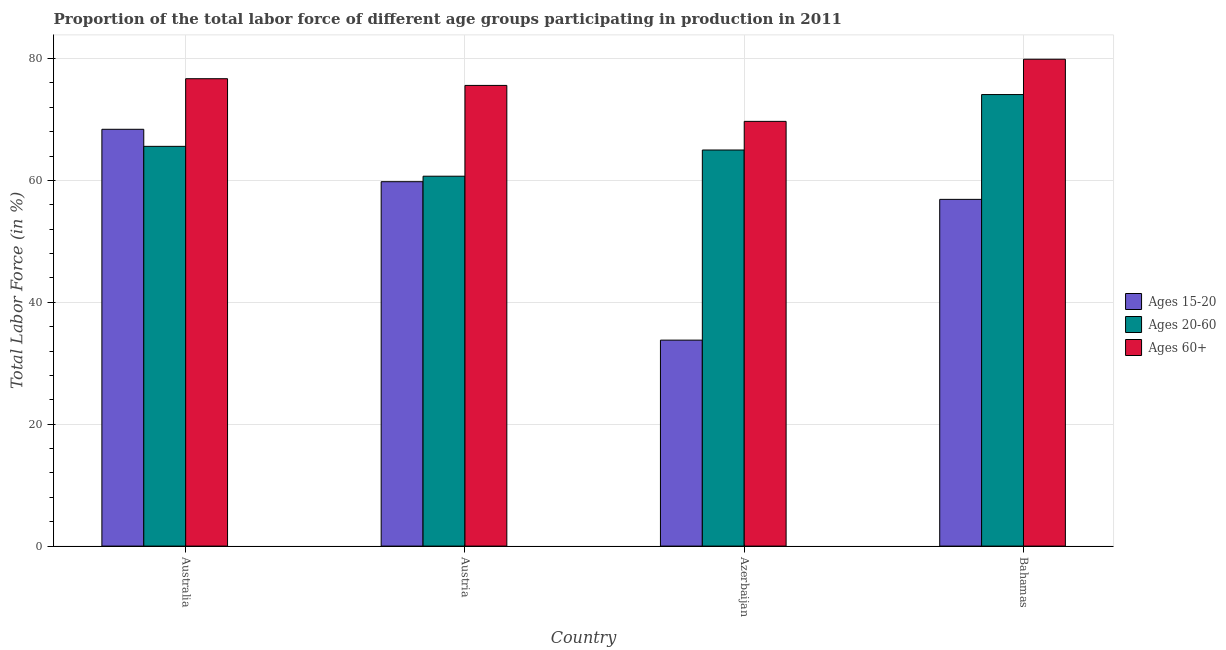How many groups of bars are there?
Make the answer very short. 4. Are the number of bars per tick equal to the number of legend labels?
Make the answer very short. Yes. What is the label of the 4th group of bars from the left?
Offer a very short reply. Bahamas. In how many cases, is the number of bars for a given country not equal to the number of legend labels?
Your answer should be very brief. 0. What is the percentage of labor force above age 60 in Australia?
Keep it short and to the point. 76.7. Across all countries, what is the maximum percentage of labor force within the age group 15-20?
Make the answer very short. 68.4. Across all countries, what is the minimum percentage of labor force within the age group 20-60?
Your answer should be compact. 60.7. In which country was the percentage of labor force within the age group 15-20 maximum?
Make the answer very short. Australia. In which country was the percentage of labor force above age 60 minimum?
Make the answer very short. Azerbaijan. What is the total percentage of labor force above age 60 in the graph?
Keep it short and to the point. 301.9. What is the difference between the percentage of labor force within the age group 15-20 in Australia and that in Austria?
Your answer should be compact. 8.6. What is the difference between the percentage of labor force above age 60 in Australia and the percentage of labor force within the age group 15-20 in Bahamas?
Provide a short and direct response. 19.8. What is the average percentage of labor force above age 60 per country?
Your answer should be compact. 75.47. What is the difference between the percentage of labor force within the age group 20-60 and percentage of labor force within the age group 15-20 in Azerbaijan?
Offer a very short reply. 31.2. What is the ratio of the percentage of labor force within the age group 15-20 in Australia to that in Azerbaijan?
Your answer should be compact. 2.02. Is the percentage of labor force within the age group 20-60 in Azerbaijan less than that in Bahamas?
Offer a terse response. Yes. What is the difference between the highest and the second highest percentage of labor force within the age group 15-20?
Provide a short and direct response. 8.6. What is the difference between the highest and the lowest percentage of labor force within the age group 15-20?
Offer a terse response. 34.6. In how many countries, is the percentage of labor force above age 60 greater than the average percentage of labor force above age 60 taken over all countries?
Give a very brief answer. 3. Is the sum of the percentage of labor force within the age group 15-20 in Australia and Austria greater than the maximum percentage of labor force within the age group 20-60 across all countries?
Your answer should be very brief. Yes. What does the 3rd bar from the left in Bahamas represents?
Give a very brief answer. Ages 60+. What does the 1st bar from the right in Azerbaijan represents?
Your answer should be very brief. Ages 60+. How many bars are there?
Ensure brevity in your answer.  12. What is the difference between two consecutive major ticks on the Y-axis?
Provide a succinct answer. 20. Are the values on the major ticks of Y-axis written in scientific E-notation?
Provide a succinct answer. No. Does the graph contain grids?
Your answer should be very brief. Yes. Where does the legend appear in the graph?
Keep it short and to the point. Center right. How are the legend labels stacked?
Your answer should be very brief. Vertical. What is the title of the graph?
Your answer should be very brief. Proportion of the total labor force of different age groups participating in production in 2011. Does "Infant(male)" appear as one of the legend labels in the graph?
Provide a succinct answer. No. What is the label or title of the X-axis?
Provide a short and direct response. Country. What is the label or title of the Y-axis?
Your answer should be very brief. Total Labor Force (in %). What is the Total Labor Force (in %) in Ages 15-20 in Australia?
Your answer should be compact. 68.4. What is the Total Labor Force (in %) of Ages 20-60 in Australia?
Keep it short and to the point. 65.6. What is the Total Labor Force (in %) in Ages 60+ in Australia?
Offer a very short reply. 76.7. What is the Total Labor Force (in %) in Ages 15-20 in Austria?
Your answer should be compact. 59.8. What is the Total Labor Force (in %) of Ages 20-60 in Austria?
Your answer should be very brief. 60.7. What is the Total Labor Force (in %) of Ages 60+ in Austria?
Your response must be concise. 75.6. What is the Total Labor Force (in %) in Ages 15-20 in Azerbaijan?
Make the answer very short. 33.8. What is the Total Labor Force (in %) of Ages 60+ in Azerbaijan?
Provide a short and direct response. 69.7. What is the Total Labor Force (in %) of Ages 15-20 in Bahamas?
Offer a very short reply. 56.9. What is the Total Labor Force (in %) of Ages 20-60 in Bahamas?
Provide a short and direct response. 74.1. What is the Total Labor Force (in %) of Ages 60+ in Bahamas?
Provide a short and direct response. 79.9. Across all countries, what is the maximum Total Labor Force (in %) in Ages 15-20?
Your answer should be very brief. 68.4. Across all countries, what is the maximum Total Labor Force (in %) of Ages 20-60?
Your answer should be compact. 74.1. Across all countries, what is the maximum Total Labor Force (in %) of Ages 60+?
Keep it short and to the point. 79.9. Across all countries, what is the minimum Total Labor Force (in %) of Ages 15-20?
Offer a very short reply. 33.8. Across all countries, what is the minimum Total Labor Force (in %) in Ages 20-60?
Your answer should be compact. 60.7. Across all countries, what is the minimum Total Labor Force (in %) in Ages 60+?
Give a very brief answer. 69.7. What is the total Total Labor Force (in %) in Ages 15-20 in the graph?
Offer a very short reply. 218.9. What is the total Total Labor Force (in %) in Ages 20-60 in the graph?
Your answer should be compact. 265.4. What is the total Total Labor Force (in %) of Ages 60+ in the graph?
Provide a succinct answer. 301.9. What is the difference between the Total Labor Force (in %) of Ages 15-20 in Australia and that in Austria?
Your answer should be compact. 8.6. What is the difference between the Total Labor Force (in %) in Ages 20-60 in Australia and that in Austria?
Offer a terse response. 4.9. What is the difference between the Total Labor Force (in %) in Ages 15-20 in Australia and that in Azerbaijan?
Provide a succinct answer. 34.6. What is the difference between the Total Labor Force (in %) in Ages 60+ in Australia and that in Azerbaijan?
Give a very brief answer. 7. What is the difference between the Total Labor Force (in %) in Ages 15-20 in Australia and that in Bahamas?
Offer a terse response. 11.5. What is the difference between the Total Labor Force (in %) of Ages 60+ in Australia and that in Bahamas?
Offer a very short reply. -3.2. What is the difference between the Total Labor Force (in %) of Ages 15-20 in Austria and that in Azerbaijan?
Keep it short and to the point. 26. What is the difference between the Total Labor Force (in %) in Ages 20-60 in Austria and that in Azerbaijan?
Offer a very short reply. -4.3. What is the difference between the Total Labor Force (in %) of Ages 60+ in Austria and that in Azerbaijan?
Offer a terse response. 5.9. What is the difference between the Total Labor Force (in %) of Ages 15-20 in Austria and that in Bahamas?
Offer a terse response. 2.9. What is the difference between the Total Labor Force (in %) of Ages 15-20 in Azerbaijan and that in Bahamas?
Your response must be concise. -23.1. What is the difference between the Total Labor Force (in %) of Ages 20-60 in Azerbaijan and that in Bahamas?
Your answer should be very brief. -9.1. What is the difference between the Total Labor Force (in %) in Ages 60+ in Azerbaijan and that in Bahamas?
Make the answer very short. -10.2. What is the difference between the Total Labor Force (in %) in Ages 15-20 in Australia and the Total Labor Force (in %) in Ages 20-60 in Azerbaijan?
Offer a very short reply. 3.4. What is the difference between the Total Labor Force (in %) of Ages 20-60 in Australia and the Total Labor Force (in %) of Ages 60+ in Azerbaijan?
Ensure brevity in your answer.  -4.1. What is the difference between the Total Labor Force (in %) in Ages 15-20 in Australia and the Total Labor Force (in %) in Ages 60+ in Bahamas?
Offer a very short reply. -11.5. What is the difference between the Total Labor Force (in %) in Ages 20-60 in Australia and the Total Labor Force (in %) in Ages 60+ in Bahamas?
Make the answer very short. -14.3. What is the difference between the Total Labor Force (in %) in Ages 15-20 in Austria and the Total Labor Force (in %) in Ages 20-60 in Azerbaijan?
Provide a succinct answer. -5.2. What is the difference between the Total Labor Force (in %) of Ages 20-60 in Austria and the Total Labor Force (in %) of Ages 60+ in Azerbaijan?
Keep it short and to the point. -9. What is the difference between the Total Labor Force (in %) in Ages 15-20 in Austria and the Total Labor Force (in %) in Ages 20-60 in Bahamas?
Your response must be concise. -14.3. What is the difference between the Total Labor Force (in %) of Ages 15-20 in Austria and the Total Labor Force (in %) of Ages 60+ in Bahamas?
Keep it short and to the point. -20.1. What is the difference between the Total Labor Force (in %) of Ages 20-60 in Austria and the Total Labor Force (in %) of Ages 60+ in Bahamas?
Your response must be concise. -19.2. What is the difference between the Total Labor Force (in %) in Ages 15-20 in Azerbaijan and the Total Labor Force (in %) in Ages 20-60 in Bahamas?
Provide a succinct answer. -40.3. What is the difference between the Total Labor Force (in %) of Ages 15-20 in Azerbaijan and the Total Labor Force (in %) of Ages 60+ in Bahamas?
Give a very brief answer. -46.1. What is the difference between the Total Labor Force (in %) in Ages 20-60 in Azerbaijan and the Total Labor Force (in %) in Ages 60+ in Bahamas?
Provide a succinct answer. -14.9. What is the average Total Labor Force (in %) of Ages 15-20 per country?
Make the answer very short. 54.73. What is the average Total Labor Force (in %) of Ages 20-60 per country?
Provide a short and direct response. 66.35. What is the average Total Labor Force (in %) of Ages 60+ per country?
Make the answer very short. 75.47. What is the difference between the Total Labor Force (in %) of Ages 15-20 and Total Labor Force (in %) of Ages 20-60 in Australia?
Provide a short and direct response. 2.8. What is the difference between the Total Labor Force (in %) of Ages 15-20 and Total Labor Force (in %) of Ages 60+ in Australia?
Your answer should be very brief. -8.3. What is the difference between the Total Labor Force (in %) of Ages 15-20 and Total Labor Force (in %) of Ages 20-60 in Austria?
Provide a succinct answer. -0.9. What is the difference between the Total Labor Force (in %) in Ages 15-20 and Total Labor Force (in %) in Ages 60+ in Austria?
Give a very brief answer. -15.8. What is the difference between the Total Labor Force (in %) in Ages 20-60 and Total Labor Force (in %) in Ages 60+ in Austria?
Your response must be concise. -14.9. What is the difference between the Total Labor Force (in %) in Ages 15-20 and Total Labor Force (in %) in Ages 20-60 in Azerbaijan?
Your answer should be very brief. -31.2. What is the difference between the Total Labor Force (in %) of Ages 15-20 and Total Labor Force (in %) of Ages 60+ in Azerbaijan?
Keep it short and to the point. -35.9. What is the difference between the Total Labor Force (in %) of Ages 15-20 and Total Labor Force (in %) of Ages 20-60 in Bahamas?
Give a very brief answer. -17.2. What is the difference between the Total Labor Force (in %) of Ages 15-20 and Total Labor Force (in %) of Ages 60+ in Bahamas?
Give a very brief answer. -23. What is the difference between the Total Labor Force (in %) in Ages 20-60 and Total Labor Force (in %) in Ages 60+ in Bahamas?
Provide a succinct answer. -5.8. What is the ratio of the Total Labor Force (in %) in Ages 15-20 in Australia to that in Austria?
Give a very brief answer. 1.14. What is the ratio of the Total Labor Force (in %) in Ages 20-60 in Australia to that in Austria?
Make the answer very short. 1.08. What is the ratio of the Total Labor Force (in %) in Ages 60+ in Australia to that in Austria?
Give a very brief answer. 1.01. What is the ratio of the Total Labor Force (in %) of Ages 15-20 in Australia to that in Azerbaijan?
Keep it short and to the point. 2.02. What is the ratio of the Total Labor Force (in %) of Ages 20-60 in Australia to that in Azerbaijan?
Your answer should be very brief. 1.01. What is the ratio of the Total Labor Force (in %) in Ages 60+ in Australia to that in Azerbaijan?
Your response must be concise. 1.1. What is the ratio of the Total Labor Force (in %) of Ages 15-20 in Australia to that in Bahamas?
Your answer should be compact. 1.2. What is the ratio of the Total Labor Force (in %) in Ages 20-60 in Australia to that in Bahamas?
Offer a terse response. 0.89. What is the ratio of the Total Labor Force (in %) of Ages 60+ in Australia to that in Bahamas?
Give a very brief answer. 0.96. What is the ratio of the Total Labor Force (in %) of Ages 15-20 in Austria to that in Azerbaijan?
Provide a short and direct response. 1.77. What is the ratio of the Total Labor Force (in %) of Ages 20-60 in Austria to that in Azerbaijan?
Ensure brevity in your answer.  0.93. What is the ratio of the Total Labor Force (in %) of Ages 60+ in Austria to that in Azerbaijan?
Offer a very short reply. 1.08. What is the ratio of the Total Labor Force (in %) in Ages 15-20 in Austria to that in Bahamas?
Ensure brevity in your answer.  1.05. What is the ratio of the Total Labor Force (in %) of Ages 20-60 in Austria to that in Bahamas?
Offer a very short reply. 0.82. What is the ratio of the Total Labor Force (in %) of Ages 60+ in Austria to that in Bahamas?
Your answer should be compact. 0.95. What is the ratio of the Total Labor Force (in %) of Ages 15-20 in Azerbaijan to that in Bahamas?
Offer a terse response. 0.59. What is the ratio of the Total Labor Force (in %) in Ages 20-60 in Azerbaijan to that in Bahamas?
Make the answer very short. 0.88. What is the ratio of the Total Labor Force (in %) in Ages 60+ in Azerbaijan to that in Bahamas?
Make the answer very short. 0.87. What is the difference between the highest and the second highest Total Labor Force (in %) in Ages 20-60?
Ensure brevity in your answer.  8.5. What is the difference between the highest and the second highest Total Labor Force (in %) of Ages 60+?
Keep it short and to the point. 3.2. What is the difference between the highest and the lowest Total Labor Force (in %) of Ages 15-20?
Offer a terse response. 34.6. What is the difference between the highest and the lowest Total Labor Force (in %) of Ages 20-60?
Your answer should be compact. 13.4. 